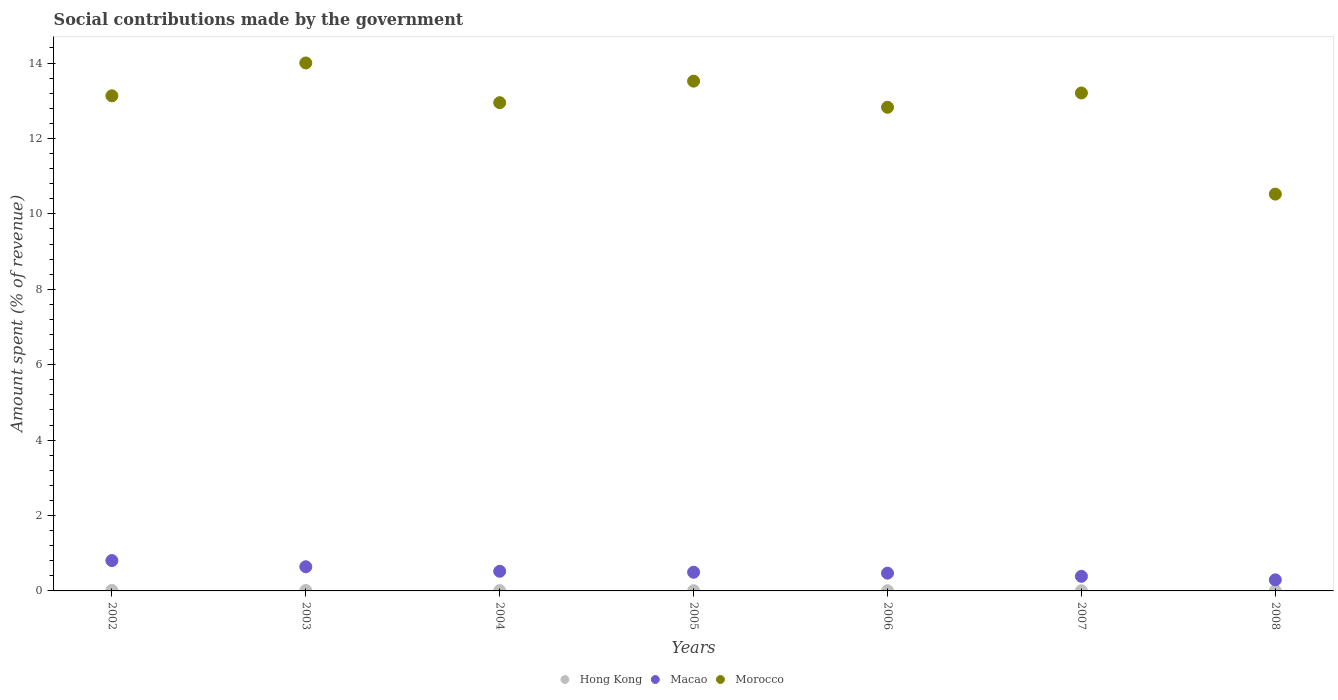What is the amount spent (in %) on social contributions in Hong Kong in 2008?
Offer a very short reply. 0. Across all years, what is the maximum amount spent (in %) on social contributions in Morocco?
Provide a succinct answer. 14. Across all years, what is the minimum amount spent (in %) on social contributions in Morocco?
Ensure brevity in your answer.  10.52. In which year was the amount spent (in %) on social contributions in Morocco maximum?
Provide a short and direct response. 2003. In which year was the amount spent (in %) on social contributions in Hong Kong minimum?
Your answer should be compact. 2007. What is the total amount spent (in %) on social contributions in Macao in the graph?
Make the answer very short. 3.62. What is the difference between the amount spent (in %) on social contributions in Hong Kong in 2005 and that in 2008?
Make the answer very short. 0. What is the difference between the amount spent (in %) on social contributions in Macao in 2006 and the amount spent (in %) on social contributions in Hong Kong in 2005?
Provide a succinct answer. 0.46. What is the average amount spent (in %) on social contributions in Morocco per year?
Provide a short and direct response. 12.88. In the year 2003, what is the difference between the amount spent (in %) on social contributions in Macao and amount spent (in %) on social contributions in Hong Kong?
Your answer should be very brief. 0.63. In how many years, is the amount spent (in %) on social contributions in Morocco greater than 4.4 %?
Provide a short and direct response. 7. What is the ratio of the amount spent (in %) on social contributions in Macao in 2003 to that in 2006?
Your response must be concise. 1.36. Is the amount spent (in %) on social contributions in Morocco in 2002 less than that in 2008?
Your answer should be compact. No. Is the difference between the amount spent (in %) on social contributions in Macao in 2005 and 2006 greater than the difference between the amount spent (in %) on social contributions in Hong Kong in 2005 and 2006?
Your answer should be compact. Yes. What is the difference between the highest and the second highest amount spent (in %) on social contributions in Macao?
Make the answer very short. 0.16. What is the difference between the highest and the lowest amount spent (in %) on social contributions in Morocco?
Offer a terse response. 3.48. In how many years, is the amount spent (in %) on social contributions in Hong Kong greater than the average amount spent (in %) on social contributions in Hong Kong taken over all years?
Keep it short and to the point. 3. Is the amount spent (in %) on social contributions in Morocco strictly greater than the amount spent (in %) on social contributions in Hong Kong over the years?
Offer a terse response. Yes. Is the amount spent (in %) on social contributions in Hong Kong strictly less than the amount spent (in %) on social contributions in Morocco over the years?
Provide a succinct answer. Yes. How many years are there in the graph?
Provide a succinct answer. 7. Does the graph contain grids?
Ensure brevity in your answer.  No. Where does the legend appear in the graph?
Provide a succinct answer. Bottom center. What is the title of the graph?
Make the answer very short. Social contributions made by the government. Does "Myanmar" appear as one of the legend labels in the graph?
Keep it short and to the point. No. What is the label or title of the X-axis?
Ensure brevity in your answer.  Years. What is the label or title of the Y-axis?
Your answer should be compact. Amount spent (% of revenue). What is the Amount spent (% of revenue) of Hong Kong in 2002?
Make the answer very short. 0.01. What is the Amount spent (% of revenue) of Macao in 2002?
Provide a succinct answer. 0.8. What is the Amount spent (% of revenue) of Morocco in 2002?
Keep it short and to the point. 13.13. What is the Amount spent (% of revenue) in Hong Kong in 2003?
Offer a very short reply. 0.01. What is the Amount spent (% of revenue) of Macao in 2003?
Offer a very short reply. 0.64. What is the Amount spent (% of revenue) in Morocco in 2003?
Provide a succinct answer. 14. What is the Amount spent (% of revenue) of Hong Kong in 2004?
Your answer should be very brief. 0.01. What is the Amount spent (% of revenue) of Macao in 2004?
Provide a short and direct response. 0.52. What is the Amount spent (% of revenue) in Morocco in 2004?
Offer a terse response. 12.95. What is the Amount spent (% of revenue) of Hong Kong in 2005?
Give a very brief answer. 0.01. What is the Amount spent (% of revenue) in Macao in 2005?
Provide a short and direct response. 0.5. What is the Amount spent (% of revenue) of Morocco in 2005?
Keep it short and to the point. 13.52. What is the Amount spent (% of revenue) in Hong Kong in 2006?
Offer a very short reply. 0.01. What is the Amount spent (% of revenue) in Macao in 2006?
Your answer should be compact. 0.47. What is the Amount spent (% of revenue) of Morocco in 2006?
Make the answer very short. 12.83. What is the Amount spent (% of revenue) in Hong Kong in 2007?
Make the answer very short. 0. What is the Amount spent (% of revenue) in Macao in 2007?
Your answer should be compact. 0.39. What is the Amount spent (% of revenue) of Morocco in 2007?
Provide a short and direct response. 13.21. What is the Amount spent (% of revenue) of Hong Kong in 2008?
Your answer should be compact. 0. What is the Amount spent (% of revenue) in Macao in 2008?
Your answer should be compact. 0.29. What is the Amount spent (% of revenue) in Morocco in 2008?
Offer a very short reply. 10.52. Across all years, what is the maximum Amount spent (% of revenue) in Hong Kong?
Ensure brevity in your answer.  0.01. Across all years, what is the maximum Amount spent (% of revenue) in Macao?
Make the answer very short. 0.8. Across all years, what is the maximum Amount spent (% of revenue) in Morocco?
Your answer should be very brief. 14. Across all years, what is the minimum Amount spent (% of revenue) of Hong Kong?
Offer a terse response. 0. Across all years, what is the minimum Amount spent (% of revenue) in Macao?
Keep it short and to the point. 0.29. Across all years, what is the minimum Amount spent (% of revenue) in Morocco?
Your answer should be very brief. 10.52. What is the total Amount spent (% of revenue) of Hong Kong in the graph?
Give a very brief answer. 0.05. What is the total Amount spent (% of revenue) in Macao in the graph?
Your answer should be compact. 3.62. What is the total Amount spent (% of revenue) in Morocco in the graph?
Your answer should be compact. 90.16. What is the difference between the Amount spent (% of revenue) in Hong Kong in 2002 and that in 2003?
Ensure brevity in your answer.  0. What is the difference between the Amount spent (% of revenue) of Macao in 2002 and that in 2003?
Keep it short and to the point. 0.16. What is the difference between the Amount spent (% of revenue) in Morocco in 2002 and that in 2003?
Make the answer very short. -0.87. What is the difference between the Amount spent (% of revenue) in Hong Kong in 2002 and that in 2004?
Ensure brevity in your answer.  0.01. What is the difference between the Amount spent (% of revenue) of Macao in 2002 and that in 2004?
Make the answer very short. 0.28. What is the difference between the Amount spent (% of revenue) of Morocco in 2002 and that in 2004?
Offer a terse response. 0.18. What is the difference between the Amount spent (% of revenue) of Hong Kong in 2002 and that in 2005?
Make the answer very short. 0.01. What is the difference between the Amount spent (% of revenue) of Macao in 2002 and that in 2005?
Your response must be concise. 0.31. What is the difference between the Amount spent (% of revenue) in Morocco in 2002 and that in 2005?
Your response must be concise. -0.39. What is the difference between the Amount spent (% of revenue) of Hong Kong in 2002 and that in 2006?
Keep it short and to the point. 0.01. What is the difference between the Amount spent (% of revenue) in Macao in 2002 and that in 2006?
Offer a very short reply. 0.33. What is the difference between the Amount spent (% of revenue) of Morocco in 2002 and that in 2006?
Your answer should be very brief. 0.3. What is the difference between the Amount spent (% of revenue) of Hong Kong in 2002 and that in 2007?
Make the answer very short. 0.01. What is the difference between the Amount spent (% of revenue) of Macao in 2002 and that in 2007?
Give a very brief answer. 0.42. What is the difference between the Amount spent (% of revenue) of Morocco in 2002 and that in 2007?
Offer a terse response. -0.08. What is the difference between the Amount spent (% of revenue) in Hong Kong in 2002 and that in 2008?
Your answer should be compact. 0.01. What is the difference between the Amount spent (% of revenue) in Macao in 2002 and that in 2008?
Offer a terse response. 0.51. What is the difference between the Amount spent (% of revenue) of Morocco in 2002 and that in 2008?
Provide a succinct answer. 2.61. What is the difference between the Amount spent (% of revenue) in Hong Kong in 2003 and that in 2004?
Ensure brevity in your answer.  0. What is the difference between the Amount spent (% of revenue) of Macao in 2003 and that in 2004?
Provide a short and direct response. 0.12. What is the difference between the Amount spent (% of revenue) in Morocco in 2003 and that in 2004?
Ensure brevity in your answer.  1.05. What is the difference between the Amount spent (% of revenue) in Hong Kong in 2003 and that in 2005?
Provide a succinct answer. 0. What is the difference between the Amount spent (% of revenue) in Macao in 2003 and that in 2005?
Your answer should be very brief. 0.15. What is the difference between the Amount spent (% of revenue) in Morocco in 2003 and that in 2005?
Offer a very short reply. 0.48. What is the difference between the Amount spent (% of revenue) in Hong Kong in 2003 and that in 2006?
Your response must be concise. 0.01. What is the difference between the Amount spent (% of revenue) in Macao in 2003 and that in 2006?
Offer a very short reply. 0.17. What is the difference between the Amount spent (% of revenue) of Morocco in 2003 and that in 2006?
Offer a terse response. 1.18. What is the difference between the Amount spent (% of revenue) in Hong Kong in 2003 and that in 2007?
Your answer should be compact. 0.01. What is the difference between the Amount spent (% of revenue) of Macao in 2003 and that in 2007?
Your answer should be compact. 0.25. What is the difference between the Amount spent (% of revenue) in Morocco in 2003 and that in 2007?
Give a very brief answer. 0.8. What is the difference between the Amount spent (% of revenue) of Hong Kong in 2003 and that in 2008?
Offer a terse response. 0.01. What is the difference between the Amount spent (% of revenue) in Macao in 2003 and that in 2008?
Make the answer very short. 0.35. What is the difference between the Amount spent (% of revenue) in Morocco in 2003 and that in 2008?
Your answer should be very brief. 3.48. What is the difference between the Amount spent (% of revenue) of Hong Kong in 2004 and that in 2005?
Provide a short and direct response. 0. What is the difference between the Amount spent (% of revenue) in Macao in 2004 and that in 2005?
Offer a very short reply. 0.03. What is the difference between the Amount spent (% of revenue) of Morocco in 2004 and that in 2005?
Provide a succinct answer. -0.57. What is the difference between the Amount spent (% of revenue) in Hong Kong in 2004 and that in 2006?
Make the answer very short. 0. What is the difference between the Amount spent (% of revenue) in Macao in 2004 and that in 2006?
Your response must be concise. 0.05. What is the difference between the Amount spent (% of revenue) of Morocco in 2004 and that in 2006?
Your answer should be very brief. 0.12. What is the difference between the Amount spent (% of revenue) in Hong Kong in 2004 and that in 2007?
Provide a short and direct response. 0. What is the difference between the Amount spent (% of revenue) in Macao in 2004 and that in 2007?
Your response must be concise. 0.13. What is the difference between the Amount spent (% of revenue) in Morocco in 2004 and that in 2007?
Make the answer very short. -0.26. What is the difference between the Amount spent (% of revenue) in Hong Kong in 2004 and that in 2008?
Your response must be concise. 0. What is the difference between the Amount spent (% of revenue) of Macao in 2004 and that in 2008?
Keep it short and to the point. 0.23. What is the difference between the Amount spent (% of revenue) in Morocco in 2004 and that in 2008?
Your response must be concise. 2.42. What is the difference between the Amount spent (% of revenue) in Hong Kong in 2005 and that in 2006?
Your response must be concise. 0. What is the difference between the Amount spent (% of revenue) in Macao in 2005 and that in 2006?
Your answer should be compact. 0.02. What is the difference between the Amount spent (% of revenue) in Morocco in 2005 and that in 2006?
Your response must be concise. 0.69. What is the difference between the Amount spent (% of revenue) in Hong Kong in 2005 and that in 2007?
Ensure brevity in your answer.  0. What is the difference between the Amount spent (% of revenue) of Macao in 2005 and that in 2007?
Keep it short and to the point. 0.11. What is the difference between the Amount spent (% of revenue) of Morocco in 2005 and that in 2007?
Keep it short and to the point. 0.31. What is the difference between the Amount spent (% of revenue) in Hong Kong in 2005 and that in 2008?
Ensure brevity in your answer.  0. What is the difference between the Amount spent (% of revenue) of Macao in 2005 and that in 2008?
Make the answer very short. 0.2. What is the difference between the Amount spent (% of revenue) in Morocco in 2005 and that in 2008?
Provide a short and direct response. 3. What is the difference between the Amount spent (% of revenue) of Hong Kong in 2006 and that in 2007?
Keep it short and to the point. 0. What is the difference between the Amount spent (% of revenue) of Macao in 2006 and that in 2007?
Offer a very short reply. 0.08. What is the difference between the Amount spent (% of revenue) in Morocco in 2006 and that in 2007?
Ensure brevity in your answer.  -0.38. What is the difference between the Amount spent (% of revenue) in Hong Kong in 2006 and that in 2008?
Give a very brief answer. 0. What is the difference between the Amount spent (% of revenue) of Macao in 2006 and that in 2008?
Offer a terse response. 0.18. What is the difference between the Amount spent (% of revenue) in Morocco in 2006 and that in 2008?
Offer a terse response. 2.3. What is the difference between the Amount spent (% of revenue) of Hong Kong in 2007 and that in 2008?
Give a very brief answer. -0. What is the difference between the Amount spent (% of revenue) in Macao in 2007 and that in 2008?
Offer a terse response. 0.09. What is the difference between the Amount spent (% of revenue) of Morocco in 2007 and that in 2008?
Keep it short and to the point. 2.68. What is the difference between the Amount spent (% of revenue) in Hong Kong in 2002 and the Amount spent (% of revenue) in Macao in 2003?
Your answer should be compact. -0.63. What is the difference between the Amount spent (% of revenue) in Hong Kong in 2002 and the Amount spent (% of revenue) in Morocco in 2003?
Your answer should be compact. -13.99. What is the difference between the Amount spent (% of revenue) in Macao in 2002 and the Amount spent (% of revenue) in Morocco in 2003?
Provide a succinct answer. -13.2. What is the difference between the Amount spent (% of revenue) of Hong Kong in 2002 and the Amount spent (% of revenue) of Macao in 2004?
Provide a succinct answer. -0.51. What is the difference between the Amount spent (% of revenue) in Hong Kong in 2002 and the Amount spent (% of revenue) in Morocco in 2004?
Keep it short and to the point. -12.94. What is the difference between the Amount spent (% of revenue) of Macao in 2002 and the Amount spent (% of revenue) of Morocco in 2004?
Provide a succinct answer. -12.14. What is the difference between the Amount spent (% of revenue) in Hong Kong in 2002 and the Amount spent (% of revenue) in Macao in 2005?
Make the answer very short. -0.48. What is the difference between the Amount spent (% of revenue) in Hong Kong in 2002 and the Amount spent (% of revenue) in Morocco in 2005?
Ensure brevity in your answer.  -13.51. What is the difference between the Amount spent (% of revenue) of Macao in 2002 and the Amount spent (% of revenue) of Morocco in 2005?
Offer a terse response. -12.72. What is the difference between the Amount spent (% of revenue) of Hong Kong in 2002 and the Amount spent (% of revenue) of Macao in 2006?
Offer a terse response. -0.46. What is the difference between the Amount spent (% of revenue) of Hong Kong in 2002 and the Amount spent (% of revenue) of Morocco in 2006?
Make the answer very short. -12.81. What is the difference between the Amount spent (% of revenue) in Macao in 2002 and the Amount spent (% of revenue) in Morocco in 2006?
Keep it short and to the point. -12.02. What is the difference between the Amount spent (% of revenue) in Hong Kong in 2002 and the Amount spent (% of revenue) in Macao in 2007?
Provide a short and direct response. -0.37. What is the difference between the Amount spent (% of revenue) of Hong Kong in 2002 and the Amount spent (% of revenue) of Morocco in 2007?
Keep it short and to the point. -13.19. What is the difference between the Amount spent (% of revenue) in Macao in 2002 and the Amount spent (% of revenue) in Morocco in 2007?
Your answer should be very brief. -12.4. What is the difference between the Amount spent (% of revenue) in Hong Kong in 2002 and the Amount spent (% of revenue) in Macao in 2008?
Your response must be concise. -0.28. What is the difference between the Amount spent (% of revenue) in Hong Kong in 2002 and the Amount spent (% of revenue) in Morocco in 2008?
Keep it short and to the point. -10.51. What is the difference between the Amount spent (% of revenue) of Macao in 2002 and the Amount spent (% of revenue) of Morocco in 2008?
Your answer should be compact. -9.72. What is the difference between the Amount spent (% of revenue) of Hong Kong in 2003 and the Amount spent (% of revenue) of Macao in 2004?
Offer a very short reply. -0.51. What is the difference between the Amount spent (% of revenue) in Hong Kong in 2003 and the Amount spent (% of revenue) in Morocco in 2004?
Ensure brevity in your answer.  -12.94. What is the difference between the Amount spent (% of revenue) in Macao in 2003 and the Amount spent (% of revenue) in Morocco in 2004?
Ensure brevity in your answer.  -12.31. What is the difference between the Amount spent (% of revenue) in Hong Kong in 2003 and the Amount spent (% of revenue) in Macao in 2005?
Offer a terse response. -0.48. What is the difference between the Amount spent (% of revenue) of Hong Kong in 2003 and the Amount spent (% of revenue) of Morocco in 2005?
Offer a terse response. -13.51. What is the difference between the Amount spent (% of revenue) in Macao in 2003 and the Amount spent (% of revenue) in Morocco in 2005?
Your response must be concise. -12.88. What is the difference between the Amount spent (% of revenue) of Hong Kong in 2003 and the Amount spent (% of revenue) of Macao in 2006?
Ensure brevity in your answer.  -0.46. What is the difference between the Amount spent (% of revenue) in Hong Kong in 2003 and the Amount spent (% of revenue) in Morocco in 2006?
Offer a very short reply. -12.82. What is the difference between the Amount spent (% of revenue) of Macao in 2003 and the Amount spent (% of revenue) of Morocco in 2006?
Offer a terse response. -12.19. What is the difference between the Amount spent (% of revenue) of Hong Kong in 2003 and the Amount spent (% of revenue) of Macao in 2007?
Make the answer very short. -0.38. What is the difference between the Amount spent (% of revenue) in Hong Kong in 2003 and the Amount spent (% of revenue) in Morocco in 2007?
Your answer should be very brief. -13.19. What is the difference between the Amount spent (% of revenue) in Macao in 2003 and the Amount spent (% of revenue) in Morocco in 2007?
Keep it short and to the point. -12.56. What is the difference between the Amount spent (% of revenue) of Hong Kong in 2003 and the Amount spent (% of revenue) of Macao in 2008?
Give a very brief answer. -0.28. What is the difference between the Amount spent (% of revenue) of Hong Kong in 2003 and the Amount spent (% of revenue) of Morocco in 2008?
Your response must be concise. -10.51. What is the difference between the Amount spent (% of revenue) of Macao in 2003 and the Amount spent (% of revenue) of Morocco in 2008?
Your answer should be compact. -9.88. What is the difference between the Amount spent (% of revenue) of Hong Kong in 2004 and the Amount spent (% of revenue) of Macao in 2005?
Offer a very short reply. -0.49. What is the difference between the Amount spent (% of revenue) in Hong Kong in 2004 and the Amount spent (% of revenue) in Morocco in 2005?
Provide a succinct answer. -13.51. What is the difference between the Amount spent (% of revenue) of Macao in 2004 and the Amount spent (% of revenue) of Morocco in 2005?
Ensure brevity in your answer.  -13. What is the difference between the Amount spent (% of revenue) of Hong Kong in 2004 and the Amount spent (% of revenue) of Macao in 2006?
Offer a terse response. -0.46. What is the difference between the Amount spent (% of revenue) in Hong Kong in 2004 and the Amount spent (% of revenue) in Morocco in 2006?
Your response must be concise. -12.82. What is the difference between the Amount spent (% of revenue) in Macao in 2004 and the Amount spent (% of revenue) in Morocco in 2006?
Offer a terse response. -12.31. What is the difference between the Amount spent (% of revenue) in Hong Kong in 2004 and the Amount spent (% of revenue) in Macao in 2007?
Offer a very short reply. -0.38. What is the difference between the Amount spent (% of revenue) of Hong Kong in 2004 and the Amount spent (% of revenue) of Morocco in 2007?
Your response must be concise. -13.2. What is the difference between the Amount spent (% of revenue) in Macao in 2004 and the Amount spent (% of revenue) in Morocco in 2007?
Give a very brief answer. -12.69. What is the difference between the Amount spent (% of revenue) of Hong Kong in 2004 and the Amount spent (% of revenue) of Macao in 2008?
Provide a succinct answer. -0.29. What is the difference between the Amount spent (% of revenue) of Hong Kong in 2004 and the Amount spent (% of revenue) of Morocco in 2008?
Your response must be concise. -10.52. What is the difference between the Amount spent (% of revenue) of Macao in 2004 and the Amount spent (% of revenue) of Morocco in 2008?
Your response must be concise. -10. What is the difference between the Amount spent (% of revenue) of Hong Kong in 2005 and the Amount spent (% of revenue) of Macao in 2006?
Provide a short and direct response. -0.46. What is the difference between the Amount spent (% of revenue) in Hong Kong in 2005 and the Amount spent (% of revenue) in Morocco in 2006?
Offer a very short reply. -12.82. What is the difference between the Amount spent (% of revenue) of Macao in 2005 and the Amount spent (% of revenue) of Morocco in 2006?
Offer a terse response. -12.33. What is the difference between the Amount spent (% of revenue) in Hong Kong in 2005 and the Amount spent (% of revenue) in Macao in 2007?
Give a very brief answer. -0.38. What is the difference between the Amount spent (% of revenue) in Hong Kong in 2005 and the Amount spent (% of revenue) in Morocco in 2007?
Your answer should be compact. -13.2. What is the difference between the Amount spent (% of revenue) in Macao in 2005 and the Amount spent (% of revenue) in Morocco in 2007?
Offer a terse response. -12.71. What is the difference between the Amount spent (% of revenue) in Hong Kong in 2005 and the Amount spent (% of revenue) in Macao in 2008?
Ensure brevity in your answer.  -0.29. What is the difference between the Amount spent (% of revenue) in Hong Kong in 2005 and the Amount spent (% of revenue) in Morocco in 2008?
Your answer should be compact. -10.52. What is the difference between the Amount spent (% of revenue) in Macao in 2005 and the Amount spent (% of revenue) in Morocco in 2008?
Your answer should be compact. -10.03. What is the difference between the Amount spent (% of revenue) in Hong Kong in 2006 and the Amount spent (% of revenue) in Macao in 2007?
Provide a short and direct response. -0.38. What is the difference between the Amount spent (% of revenue) of Hong Kong in 2006 and the Amount spent (% of revenue) of Morocco in 2007?
Your answer should be compact. -13.2. What is the difference between the Amount spent (% of revenue) of Macao in 2006 and the Amount spent (% of revenue) of Morocco in 2007?
Your answer should be compact. -12.73. What is the difference between the Amount spent (% of revenue) of Hong Kong in 2006 and the Amount spent (% of revenue) of Macao in 2008?
Your response must be concise. -0.29. What is the difference between the Amount spent (% of revenue) in Hong Kong in 2006 and the Amount spent (% of revenue) in Morocco in 2008?
Your response must be concise. -10.52. What is the difference between the Amount spent (% of revenue) of Macao in 2006 and the Amount spent (% of revenue) of Morocco in 2008?
Provide a short and direct response. -10.05. What is the difference between the Amount spent (% of revenue) in Hong Kong in 2007 and the Amount spent (% of revenue) in Macao in 2008?
Offer a terse response. -0.29. What is the difference between the Amount spent (% of revenue) in Hong Kong in 2007 and the Amount spent (% of revenue) in Morocco in 2008?
Offer a terse response. -10.52. What is the difference between the Amount spent (% of revenue) in Macao in 2007 and the Amount spent (% of revenue) in Morocco in 2008?
Your answer should be very brief. -10.14. What is the average Amount spent (% of revenue) of Hong Kong per year?
Keep it short and to the point. 0.01. What is the average Amount spent (% of revenue) of Macao per year?
Your answer should be compact. 0.52. What is the average Amount spent (% of revenue) in Morocco per year?
Ensure brevity in your answer.  12.88. In the year 2002, what is the difference between the Amount spent (% of revenue) in Hong Kong and Amount spent (% of revenue) in Macao?
Ensure brevity in your answer.  -0.79. In the year 2002, what is the difference between the Amount spent (% of revenue) of Hong Kong and Amount spent (% of revenue) of Morocco?
Give a very brief answer. -13.12. In the year 2002, what is the difference between the Amount spent (% of revenue) in Macao and Amount spent (% of revenue) in Morocco?
Your answer should be very brief. -12.33. In the year 2003, what is the difference between the Amount spent (% of revenue) in Hong Kong and Amount spent (% of revenue) in Macao?
Make the answer very short. -0.63. In the year 2003, what is the difference between the Amount spent (% of revenue) in Hong Kong and Amount spent (% of revenue) in Morocco?
Provide a short and direct response. -13.99. In the year 2003, what is the difference between the Amount spent (% of revenue) in Macao and Amount spent (% of revenue) in Morocco?
Keep it short and to the point. -13.36. In the year 2004, what is the difference between the Amount spent (% of revenue) in Hong Kong and Amount spent (% of revenue) in Macao?
Provide a succinct answer. -0.51. In the year 2004, what is the difference between the Amount spent (% of revenue) of Hong Kong and Amount spent (% of revenue) of Morocco?
Provide a succinct answer. -12.94. In the year 2004, what is the difference between the Amount spent (% of revenue) in Macao and Amount spent (% of revenue) in Morocco?
Make the answer very short. -12.43. In the year 2005, what is the difference between the Amount spent (% of revenue) of Hong Kong and Amount spent (% of revenue) of Macao?
Keep it short and to the point. -0.49. In the year 2005, what is the difference between the Amount spent (% of revenue) in Hong Kong and Amount spent (% of revenue) in Morocco?
Your response must be concise. -13.51. In the year 2005, what is the difference between the Amount spent (% of revenue) in Macao and Amount spent (% of revenue) in Morocco?
Offer a terse response. -13.02. In the year 2006, what is the difference between the Amount spent (% of revenue) of Hong Kong and Amount spent (% of revenue) of Macao?
Offer a terse response. -0.47. In the year 2006, what is the difference between the Amount spent (% of revenue) in Hong Kong and Amount spent (% of revenue) in Morocco?
Offer a very short reply. -12.82. In the year 2006, what is the difference between the Amount spent (% of revenue) of Macao and Amount spent (% of revenue) of Morocco?
Provide a short and direct response. -12.36. In the year 2007, what is the difference between the Amount spent (% of revenue) of Hong Kong and Amount spent (% of revenue) of Macao?
Keep it short and to the point. -0.38. In the year 2007, what is the difference between the Amount spent (% of revenue) in Hong Kong and Amount spent (% of revenue) in Morocco?
Provide a succinct answer. -13.2. In the year 2007, what is the difference between the Amount spent (% of revenue) in Macao and Amount spent (% of revenue) in Morocco?
Make the answer very short. -12.82. In the year 2008, what is the difference between the Amount spent (% of revenue) in Hong Kong and Amount spent (% of revenue) in Macao?
Your answer should be very brief. -0.29. In the year 2008, what is the difference between the Amount spent (% of revenue) of Hong Kong and Amount spent (% of revenue) of Morocco?
Offer a terse response. -10.52. In the year 2008, what is the difference between the Amount spent (% of revenue) in Macao and Amount spent (% of revenue) in Morocco?
Offer a terse response. -10.23. What is the ratio of the Amount spent (% of revenue) in Hong Kong in 2002 to that in 2003?
Provide a succinct answer. 1.21. What is the ratio of the Amount spent (% of revenue) in Macao in 2002 to that in 2003?
Offer a terse response. 1.26. What is the ratio of the Amount spent (% of revenue) in Morocco in 2002 to that in 2003?
Provide a short and direct response. 0.94. What is the ratio of the Amount spent (% of revenue) in Hong Kong in 2002 to that in 2004?
Provide a short and direct response. 1.68. What is the ratio of the Amount spent (% of revenue) in Macao in 2002 to that in 2004?
Ensure brevity in your answer.  1.54. What is the ratio of the Amount spent (% of revenue) in Morocco in 2002 to that in 2004?
Offer a terse response. 1.01. What is the ratio of the Amount spent (% of revenue) of Hong Kong in 2002 to that in 2005?
Provide a succinct answer. 2.1. What is the ratio of the Amount spent (% of revenue) of Macao in 2002 to that in 2005?
Provide a short and direct response. 1.62. What is the ratio of the Amount spent (% of revenue) in Morocco in 2002 to that in 2005?
Provide a succinct answer. 0.97. What is the ratio of the Amount spent (% of revenue) of Hong Kong in 2002 to that in 2006?
Your answer should be compact. 2.45. What is the ratio of the Amount spent (% of revenue) of Macao in 2002 to that in 2006?
Give a very brief answer. 1.71. What is the ratio of the Amount spent (% of revenue) in Morocco in 2002 to that in 2006?
Your response must be concise. 1.02. What is the ratio of the Amount spent (% of revenue) of Hong Kong in 2002 to that in 2007?
Give a very brief answer. 2.96. What is the ratio of the Amount spent (% of revenue) in Macao in 2002 to that in 2007?
Provide a succinct answer. 2.08. What is the ratio of the Amount spent (% of revenue) in Hong Kong in 2002 to that in 2008?
Make the answer very short. 2.82. What is the ratio of the Amount spent (% of revenue) in Macao in 2002 to that in 2008?
Provide a short and direct response. 2.74. What is the ratio of the Amount spent (% of revenue) of Morocco in 2002 to that in 2008?
Your response must be concise. 1.25. What is the ratio of the Amount spent (% of revenue) in Hong Kong in 2003 to that in 2004?
Provide a short and direct response. 1.39. What is the ratio of the Amount spent (% of revenue) in Macao in 2003 to that in 2004?
Give a very brief answer. 1.23. What is the ratio of the Amount spent (% of revenue) of Morocco in 2003 to that in 2004?
Make the answer very short. 1.08. What is the ratio of the Amount spent (% of revenue) of Hong Kong in 2003 to that in 2005?
Provide a succinct answer. 1.73. What is the ratio of the Amount spent (% of revenue) in Macao in 2003 to that in 2005?
Offer a terse response. 1.29. What is the ratio of the Amount spent (% of revenue) in Morocco in 2003 to that in 2005?
Offer a very short reply. 1.04. What is the ratio of the Amount spent (% of revenue) of Hong Kong in 2003 to that in 2006?
Ensure brevity in your answer.  2.02. What is the ratio of the Amount spent (% of revenue) in Macao in 2003 to that in 2006?
Give a very brief answer. 1.36. What is the ratio of the Amount spent (% of revenue) in Morocco in 2003 to that in 2006?
Give a very brief answer. 1.09. What is the ratio of the Amount spent (% of revenue) in Hong Kong in 2003 to that in 2007?
Keep it short and to the point. 2.44. What is the ratio of the Amount spent (% of revenue) of Macao in 2003 to that in 2007?
Keep it short and to the point. 1.65. What is the ratio of the Amount spent (% of revenue) in Morocco in 2003 to that in 2007?
Make the answer very short. 1.06. What is the ratio of the Amount spent (% of revenue) in Hong Kong in 2003 to that in 2008?
Offer a very short reply. 2.32. What is the ratio of the Amount spent (% of revenue) of Macao in 2003 to that in 2008?
Your answer should be very brief. 2.18. What is the ratio of the Amount spent (% of revenue) of Morocco in 2003 to that in 2008?
Keep it short and to the point. 1.33. What is the ratio of the Amount spent (% of revenue) of Hong Kong in 2004 to that in 2005?
Ensure brevity in your answer.  1.25. What is the ratio of the Amount spent (% of revenue) in Macao in 2004 to that in 2005?
Your answer should be compact. 1.05. What is the ratio of the Amount spent (% of revenue) in Morocco in 2004 to that in 2005?
Offer a terse response. 0.96. What is the ratio of the Amount spent (% of revenue) in Hong Kong in 2004 to that in 2006?
Your response must be concise. 1.46. What is the ratio of the Amount spent (% of revenue) in Macao in 2004 to that in 2006?
Provide a succinct answer. 1.11. What is the ratio of the Amount spent (% of revenue) of Morocco in 2004 to that in 2006?
Your answer should be compact. 1.01. What is the ratio of the Amount spent (% of revenue) in Hong Kong in 2004 to that in 2007?
Your response must be concise. 1.76. What is the ratio of the Amount spent (% of revenue) of Macao in 2004 to that in 2007?
Ensure brevity in your answer.  1.34. What is the ratio of the Amount spent (% of revenue) in Morocco in 2004 to that in 2007?
Your response must be concise. 0.98. What is the ratio of the Amount spent (% of revenue) in Hong Kong in 2004 to that in 2008?
Offer a very short reply. 1.67. What is the ratio of the Amount spent (% of revenue) of Macao in 2004 to that in 2008?
Keep it short and to the point. 1.77. What is the ratio of the Amount spent (% of revenue) of Morocco in 2004 to that in 2008?
Your answer should be compact. 1.23. What is the ratio of the Amount spent (% of revenue) in Macao in 2005 to that in 2006?
Make the answer very short. 1.05. What is the ratio of the Amount spent (% of revenue) of Morocco in 2005 to that in 2006?
Offer a terse response. 1.05. What is the ratio of the Amount spent (% of revenue) in Hong Kong in 2005 to that in 2007?
Provide a succinct answer. 1.41. What is the ratio of the Amount spent (% of revenue) of Macao in 2005 to that in 2007?
Your answer should be compact. 1.28. What is the ratio of the Amount spent (% of revenue) in Morocco in 2005 to that in 2007?
Provide a succinct answer. 1.02. What is the ratio of the Amount spent (% of revenue) in Hong Kong in 2005 to that in 2008?
Give a very brief answer. 1.34. What is the ratio of the Amount spent (% of revenue) in Macao in 2005 to that in 2008?
Offer a terse response. 1.68. What is the ratio of the Amount spent (% of revenue) in Morocco in 2005 to that in 2008?
Make the answer very short. 1.28. What is the ratio of the Amount spent (% of revenue) of Hong Kong in 2006 to that in 2007?
Give a very brief answer. 1.21. What is the ratio of the Amount spent (% of revenue) in Macao in 2006 to that in 2007?
Provide a short and direct response. 1.22. What is the ratio of the Amount spent (% of revenue) of Morocco in 2006 to that in 2007?
Make the answer very short. 0.97. What is the ratio of the Amount spent (% of revenue) in Hong Kong in 2006 to that in 2008?
Make the answer very short. 1.15. What is the ratio of the Amount spent (% of revenue) of Macao in 2006 to that in 2008?
Your answer should be compact. 1.6. What is the ratio of the Amount spent (% of revenue) of Morocco in 2006 to that in 2008?
Offer a terse response. 1.22. What is the ratio of the Amount spent (% of revenue) of Hong Kong in 2007 to that in 2008?
Offer a terse response. 0.95. What is the ratio of the Amount spent (% of revenue) of Macao in 2007 to that in 2008?
Provide a short and direct response. 1.32. What is the ratio of the Amount spent (% of revenue) of Morocco in 2007 to that in 2008?
Give a very brief answer. 1.25. What is the difference between the highest and the second highest Amount spent (% of revenue) of Hong Kong?
Give a very brief answer. 0. What is the difference between the highest and the second highest Amount spent (% of revenue) in Macao?
Make the answer very short. 0.16. What is the difference between the highest and the second highest Amount spent (% of revenue) of Morocco?
Offer a very short reply. 0.48. What is the difference between the highest and the lowest Amount spent (% of revenue) of Hong Kong?
Your response must be concise. 0.01. What is the difference between the highest and the lowest Amount spent (% of revenue) of Macao?
Make the answer very short. 0.51. What is the difference between the highest and the lowest Amount spent (% of revenue) of Morocco?
Your answer should be compact. 3.48. 